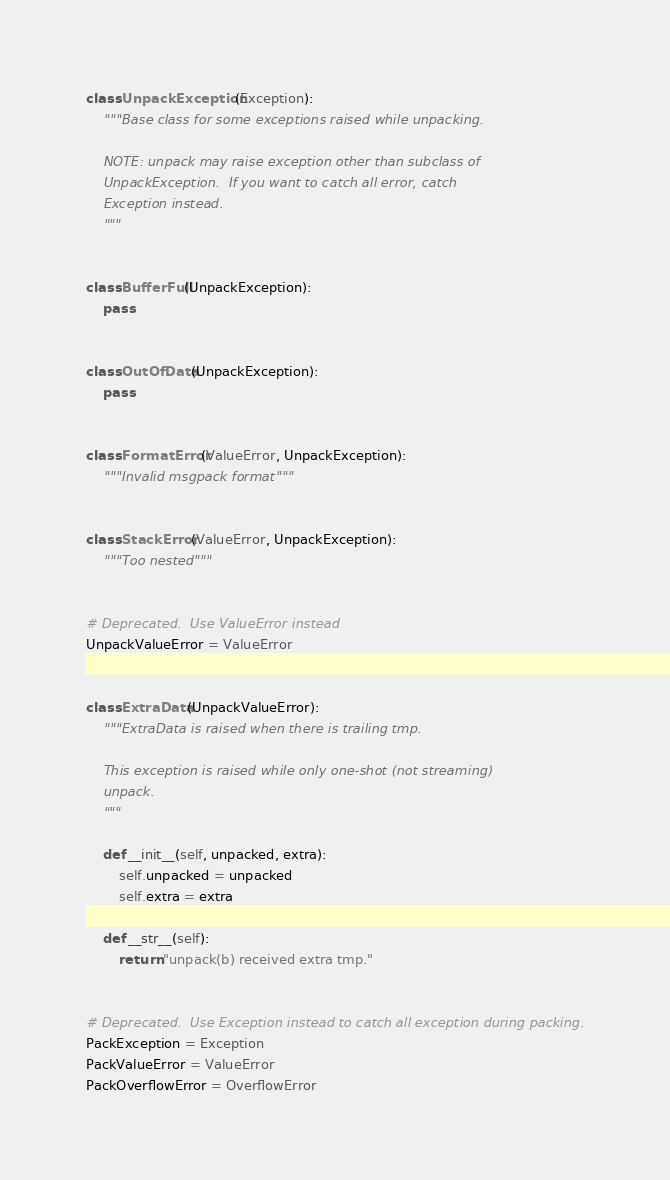<code> <loc_0><loc_0><loc_500><loc_500><_Python_>class UnpackException(Exception):
    """Base class for some exceptions raised while unpacking.

    NOTE: unpack may raise exception other than subclass of
    UnpackException.  If you want to catch all error, catch
    Exception instead.
    """


class BufferFull(UnpackException):
    pass


class OutOfData(UnpackException):
    pass


class FormatError(ValueError, UnpackException):
    """Invalid msgpack format"""


class StackError(ValueError, UnpackException):
    """Too nested"""


# Deprecated.  Use ValueError instead
UnpackValueError = ValueError


class ExtraData(UnpackValueError):
    """ExtraData is raised when there is trailing tmp.

    This exception is raised while only one-shot (not streaming)
    unpack.
    """

    def __init__(self, unpacked, extra):
        self.unpacked = unpacked
        self.extra = extra

    def __str__(self):
        return "unpack(b) received extra tmp."


# Deprecated.  Use Exception instead to catch all exception during packing.
PackException = Exception
PackValueError = ValueError
PackOverflowError = OverflowError
</code> 